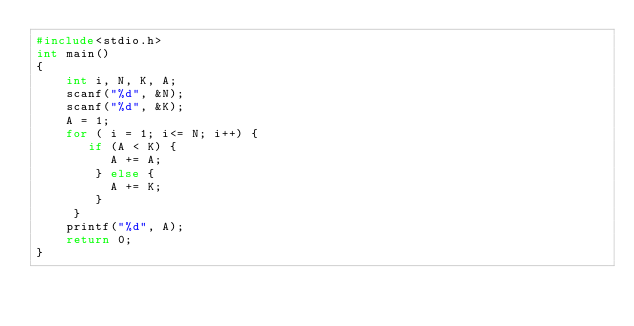<code> <loc_0><loc_0><loc_500><loc_500><_C_>#include<stdio.h>
int main()
{
    int i, N, K, A;
    scanf("%d", &N);
    scanf("%d", &K);
    A = 1;
    for ( i = 1; i<= N; i++) {
       if (A < K) {
          A += A;
        } else {
          A += K;
        }
     }
    printf("%d", A);
    return 0;
}
</code> 